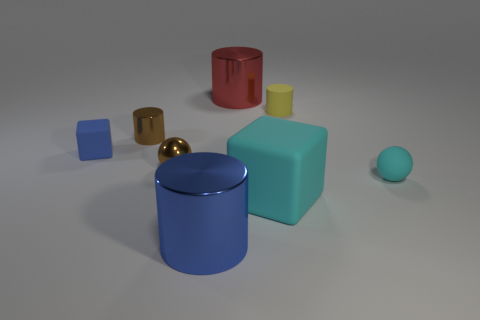Subtract all shiny cylinders. How many cylinders are left? 1 Subtract all blue cylinders. How many cylinders are left? 3 Subtract 2 cylinders. How many cylinders are left? 2 Add 1 big metallic objects. How many objects exist? 9 Subtract all yellow cylinders. Subtract all red blocks. How many cylinders are left? 3 Subtract all spheres. How many objects are left? 6 Add 7 small yellow rubber cylinders. How many small yellow rubber cylinders are left? 8 Add 1 tiny brown cylinders. How many tiny brown cylinders exist? 2 Subtract 0 red cubes. How many objects are left? 8 Subtract all cyan rubber things. Subtract all brown metal objects. How many objects are left? 4 